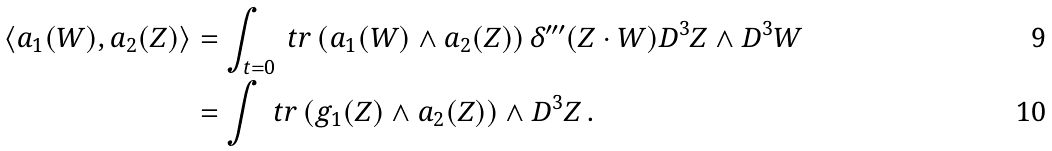Convert formula to latex. <formula><loc_0><loc_0><loc_500><loc_500>\langle a _ { 1 } ( W ) , a _ { 2 } ( Z ) \rangle & = \int _ { t = 0 } \ t r \, ( a _ { 1 } ( W ) \wedge a _ { 2 } ( Z ) ) \, \delta ^ { \prime \prime \prime } ( Z \cdot W ) D ^ { 3 } Z \wedge D ^ { 3 } W \\ & = \int \ t r \, ( g _ { 1 } ( Z ) \wedge a _ { 2 } ( Z ) ) \wedge D ^ { 3 } Z \, .</formula> 